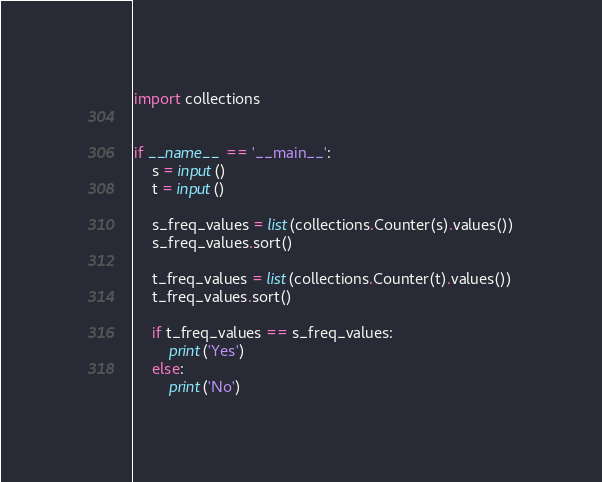Convert code to text. <code><loc_0><loc_0><loc_500><loc_500><_Python_>import collections


if __name__ == '__main__':
    s = input()
    t = input()

    s_freq_values = list(collections.Counter(s).values())
    s_freq_values.sort()

    t_freq_values = list(collections.Counter(t).values())
    t_freq_values.sort()

    if t_freq_values == s_freq_values:
        print('Yes')
    else:
        print('No')
</code> 